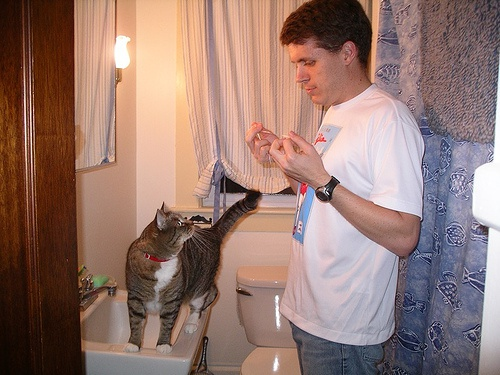Describe the objects in this image and their specific colors. I can see people in black, lightgray, brown, darkgray, and lightpink tones, cat in black, maroon, and gray tones, sink in black and gray tones, and toilet in black, gray, salmon, and darkgray tones in this image. 